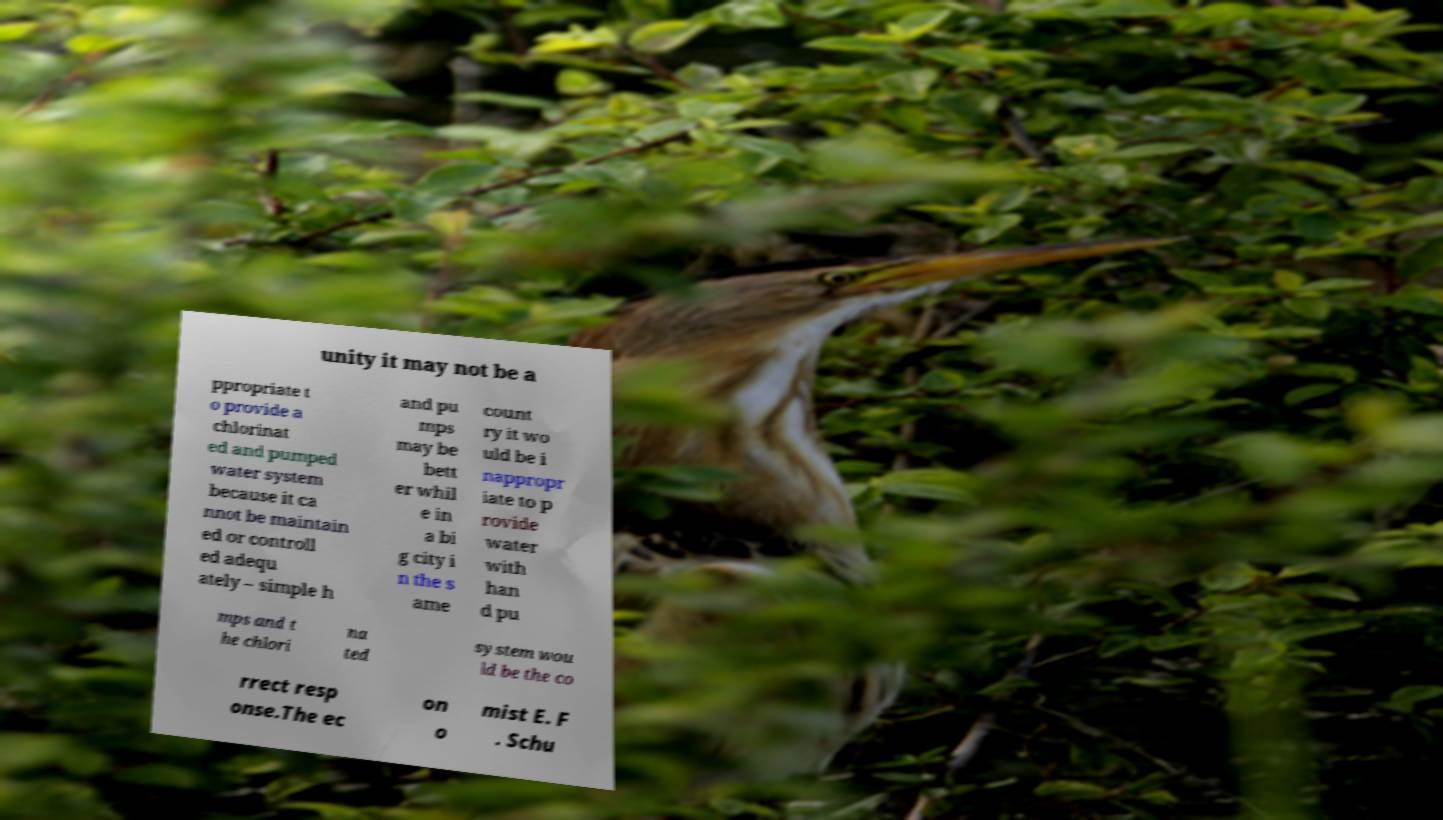Could you extract and type out the text from this image? unity it may not be a ppropriate t o provide a chlorinat ed and pumped water system because it ca nnot be maintain ed or controll ed adequ ately – simple h and pu mps may be bett er whil e in a bi g city i n the s ame count ry it wo uld be i nappropr iate to p rovide water with han d pu mps and t he chlori na ted system wou ld be the co rrect resp onse.The ec on o mist E. F . Schu 